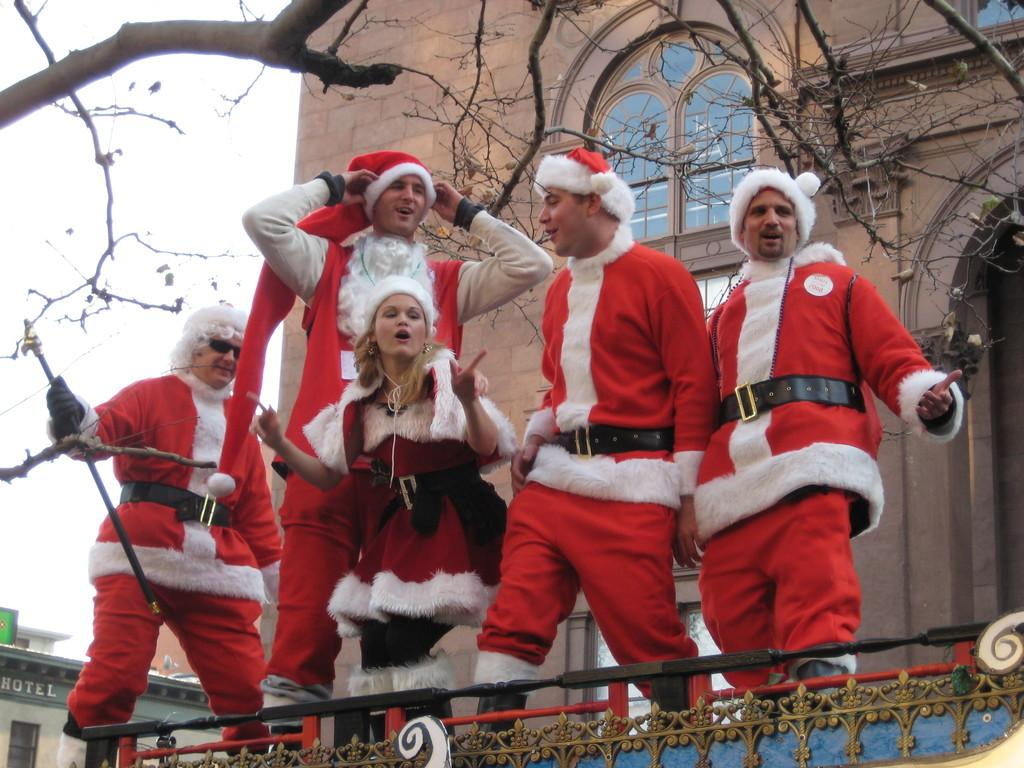What are the people in the center of the image wearing? The people in the center of the image are wearing costumes. What can be seen in the background of the image? There is a building and trees in the background of the image. What is visible in the sky in the image? The sky is visible in the background of the image. What type of glove is the doll wearing in the image? There is no doll present in the image, and therefore no glove to be worn. 